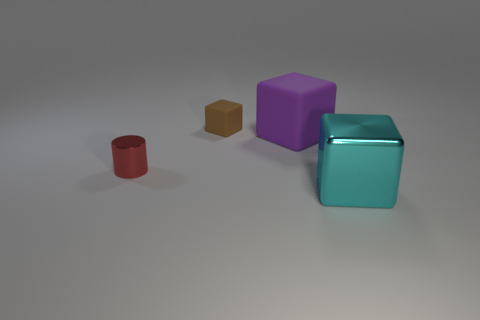What is the material of the object that is behind the big cube that is to the left of the big cube that is in front of the tiny cylinder?
Your response must be concise. Rubber. There is a metal object that is in front of the small red shiny object; is it the same color as the rubber object in front of the tiny brown object?
Offer a very short reply. No. There is a metallic object on the left side of the brown cube that is behind the cube in front of the red shiny thing; what is its shape?
Offer a very short reply. Cylinder. The object that is both on the left side of the big rubber block and in front of the large matte cube has what shape?
Your answer should be very brief. Cylinder. There is a big block that is behind the object in front of the red metal cylinder; what number of purple things are behind it?
Offer a very short reply. 0. There is a brown thing that is the same shape as the cyan metal object; what size is it?
Your answer should be compact. Small. Is there anything else that is the same size as the red thing?
Your response must be concise. Yes. Do the small object behind the tiny red thing and the tiny cylinder have the same material?
Ensure brevity in your answer.  No. There is a metal object that is the same shape as the brown rubber thing; what color is it?
Provide a succinct answer. Cyan. How many other things are there of the same color as the tiny metal thing?
Provide a succinct answer. 0. 